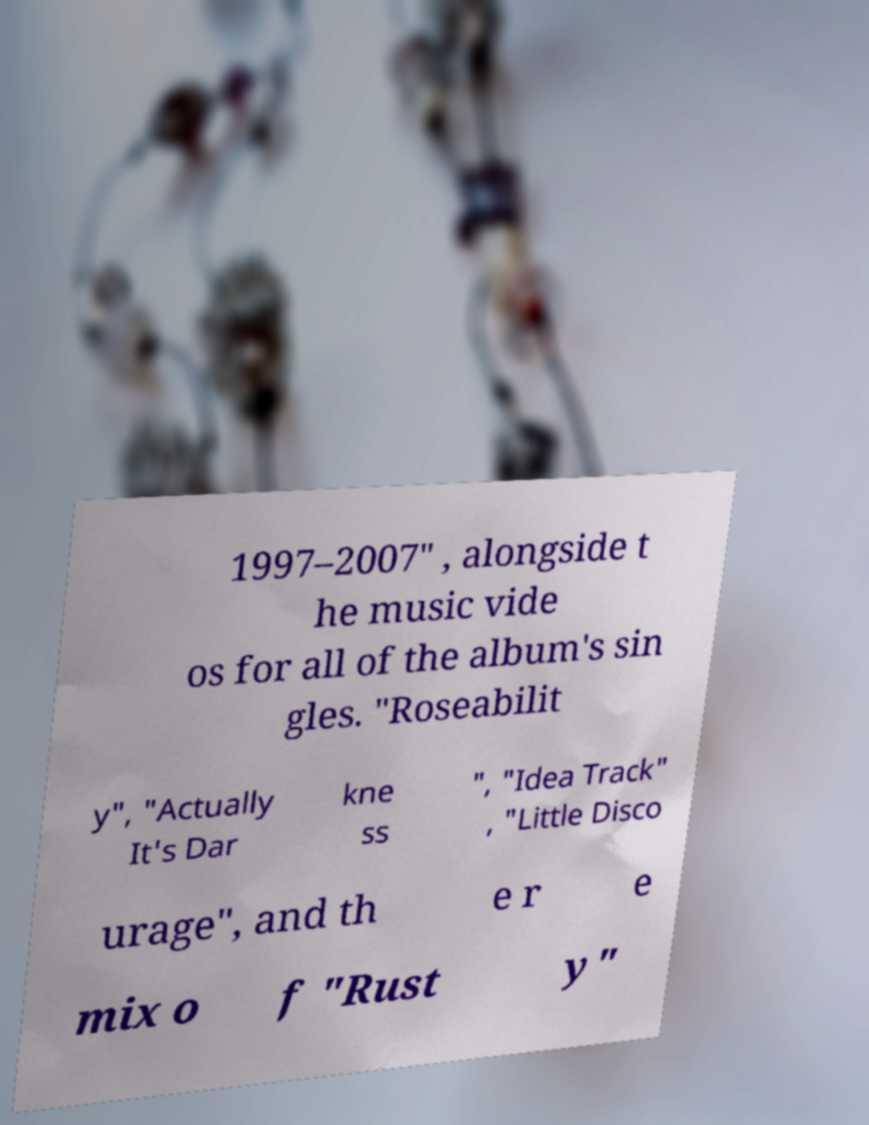Please read and relay the text visible in this image. What does it say? 1997–2007" , alongside t he music vide os for all of the album's sin gles. "Roseabilit y", "Actually It's Dar kne ss ", "Idea Track" , "Little Disco urage", and th e r e mix o f "Rust y" 